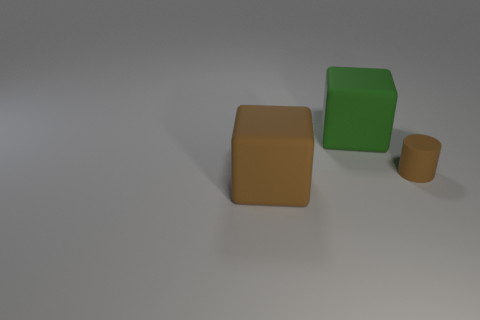How many things are either brown things right of the green object or tiny objects?
Offer a terse response. 1. What number of green things are either large matte things or matte objects?
Ensure brevity in your answer.  1. How many other objects are there of the same color as the matte cylinder?
Your response must be concise. 1. Are there fewer rubber things that are in front of the big green thing than big yellow metal things?
Provide a succinct answer. No. There is a block that is behind the rubber cube in front of the large green rubber cube that is left of the small brown cylinder; what color is it?
Offer a very short reply. Green. There is another rubber object that is the same shape as the big green thing; what size is it?
Keep it short and to the point. Large. Are there fewer large green matte blocks that are to the left of the green matte thing than green blocks that are left of the brown cylinder?
Provide a succinct answer. Yes. The rubber thing that is to the right of the big brown block and left of the small brown thing has what shape?
Offer a very short reply. Cube. What is the size of the green object that is made of the same material as the brown block?
Offer a terse response. Large. There is a cylinder; is its color the same as the big block in front of the small rubber cylinder?
Offer a very short reply. Yes. 